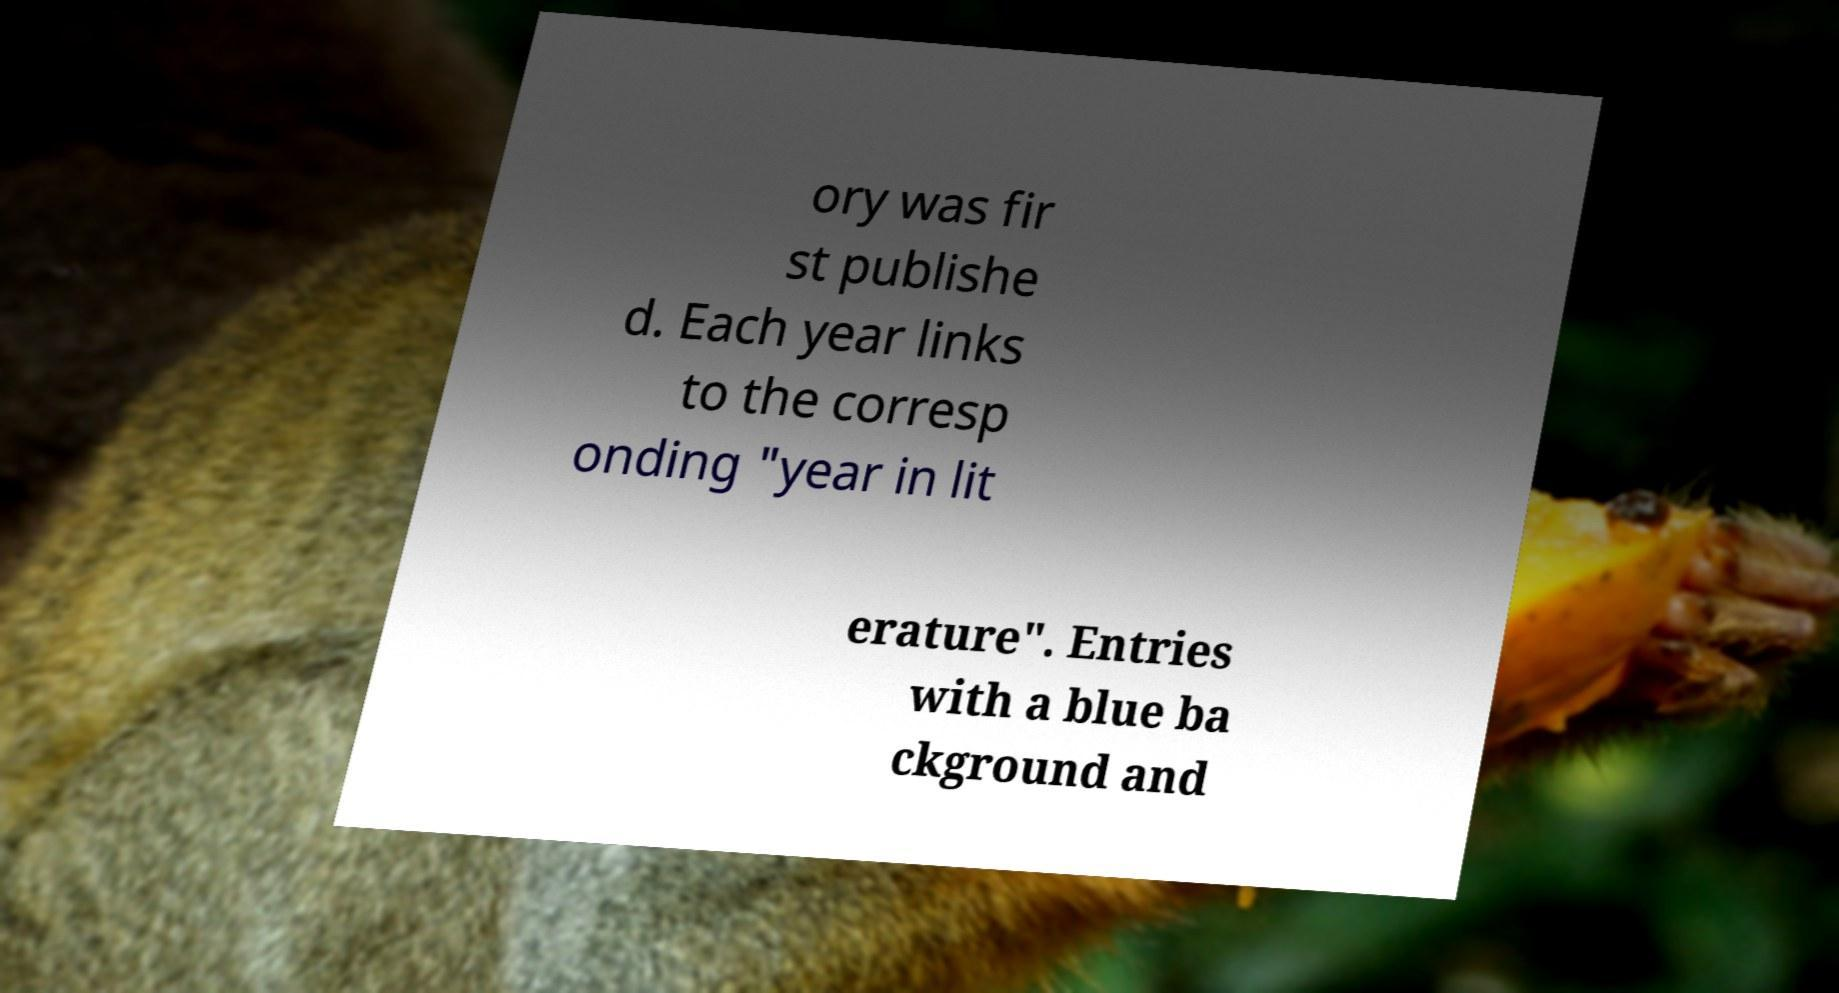Could you assist in decoding the text presented in this image and type it out clearly? ory was fir st publishe d. Each year links to the corresp onding "year in lit erature". Entries with a blue ba ckground and 